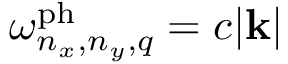Convert formula to latex. <formula><loc_0><loc_0><loc_500><loc_500>\omega _ { n _ { x } , n _ { y } , q } ^ { p h } = c | k |</formula> 